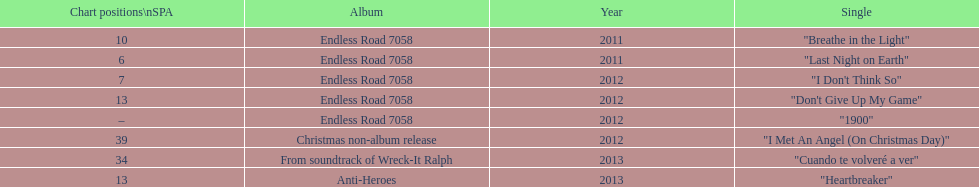Based on sales figures, what auryn album is the most popular? Endless Road 7058. 